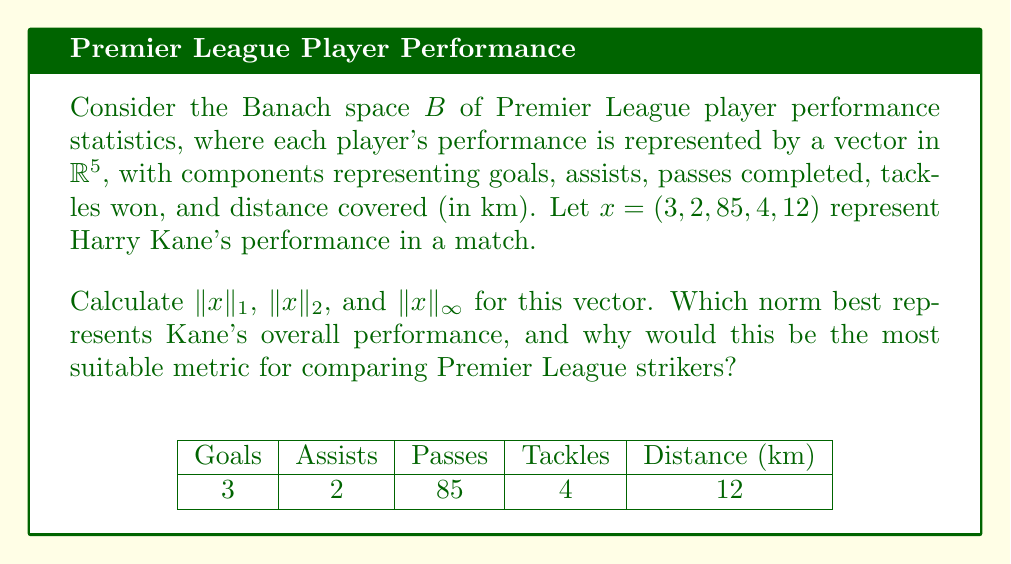Can you solve this math problem? To solve this problem, we'll calculate the three norms and then interpret the results in the context of Premier League football.

1. $\|x\|_1$ (Manhattan norm):
   $$\|x\|_1 = \sum_{i=1}^5 |x_i| = |3| + |2| + |85| + |4| + |12| = 106$$

2. $\|x\|_2$ (Euclidean norm):
   $$\|x\|_2 = \sqrt{\sum_{i=1}^5 x_i^2} = \sqrt{3^2 + 2^2 + 85^2 + 4^2 + 12^2} = \sqrt{7358} \approx 85.78$$

3. $\|x\|_\infty$ (Maximum norm):
   $$\|x\|_\infty = \max_{i=1,\ldots,5} |x_i| = 85$$

Interpreting the results:

The $\|x\|_1$ norm gives equal weight to all statistics, which might not be ideal for a striker like Kane, as it doesn't prioritize goal-scoring.

The $\|x\|_2$ norm emphasizes larger values more than smaller ones, which could be suitable for Kane as it would highlight his goal-scoring ability.

The $\|x\|_\infty$ norm only considers the largest value, which in this case is the number of passes completed. This doesn't capture the overall performance of a striker.

For Premier League strikers, the Euclidean norm ($\|x\|_2$) would be the most suitable metric. It gives more weight to larger values (like goals and assists) without completely ignoring other aspects of performance. This aligns well with the Premier League's emphasis on well-rounded strikers who contribute to both scoring and build-up play.
Answer: $\|x\|_2 \approx 85.78$; Euclidean norm best represents Kane's performance 